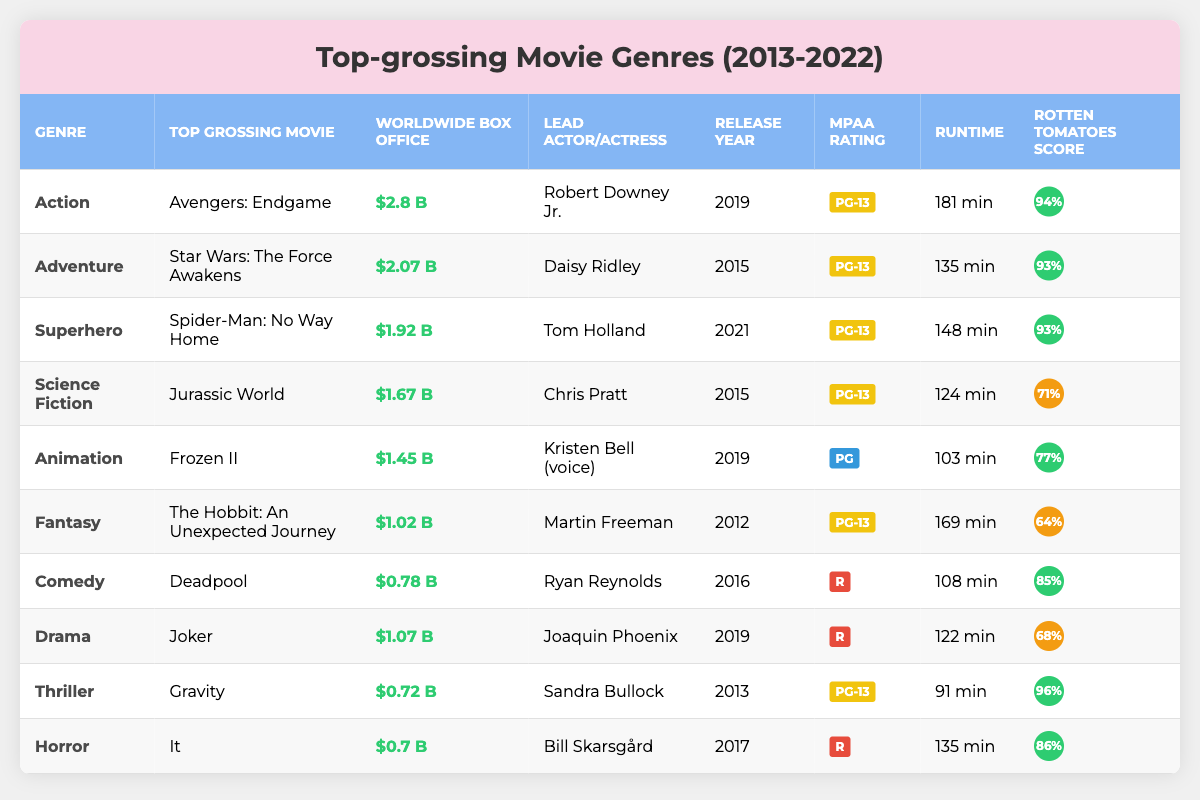What is the top-grossing movie of all time from the genre "Action"? In the table under the "Top Grossing Movie" column for the "Action" genre, the entry reads "Avengers: Endgame."
Answer: Avengers: Endgame Which movie has a higher Rotten Tomatoes score, "Frozen II" or "Jurassic World"? In the Rotten Tomatoes Score column, "Frozen II" has a score of 77%, and "Jurassic World" has a score of 71%. Since 77% is greater than 71%, "Frozen II" has the higher score.
Answer: Frozen II What is the total worldwide box office for the "Comedy" and "Horror" genres combined? For "Comedy," the box office is 0.78 billion USD, and for "Horror," it is 0.70 billion USD. Adding those amounts together, 0.78 + 0.70 = 1.48 billion USD.
Answer: 1.48 billion USD Which lead actor starred in the movie with the highest box office revenue? Looking at the "Worldwide Box Office" column, "Avengers: Endgame" has the highest revenue at 2.80 billion USD. The lead actor for this movie is Robert Downey Jr.
Answer: Robert Downey Jr What is the release year of the highest grossing "Science Fiction" movie? The highest grossing "Science Fiction" movie in the table is "Jurassic World," which was released in 2015.
Answer: 2015 Is the movie "Joker" rated R? In the MPAA rating column for the film "Joker," it shows an "R" rating. Thus, the answer is yes, "Joker" is rated R.
Answer: Yes What is the average runtime of "Adventure" and "Drama" movies listed in the table? The runtime for "Adventure" is 135 minutes for "Star Wars: The Force Awakens," and for "Drama," it's 122 minutes for "Joker." The average is calculated as (135 + 122) / 2 = 127.5 minutes.
Answer: 127.5 minutes Which genre has the lowest Rotten Tomatoes score listed in the table? In the Rotten Tomatoes Score column, "The Hobbit: An Unexpected Journey" (Fantasy) has the lowest score at 64%. Therefore, the Fantasy genre has the lowest score.
Answer: Fantasy What is the difference in worldwide box office between "Spider-Man: No Way Home" and "Deadpool"? "Spider-Man: No Way Home" has a box office of 1.92 billion USD, and "Deadpool" has 0.78 billion USD. The difference is calculated as 1.92 - 0.78 = 1.14 billion USD.
Answer: 1.14 billion USD Which movie released in 2019 had the highest Rotten Tomatoes score? The movie "Avengers: Endgame," released in 2019, has a Rotten Tomatoes score of 94%, which is higher than any other movie released that year.
Answer: Avengers: Endgame 